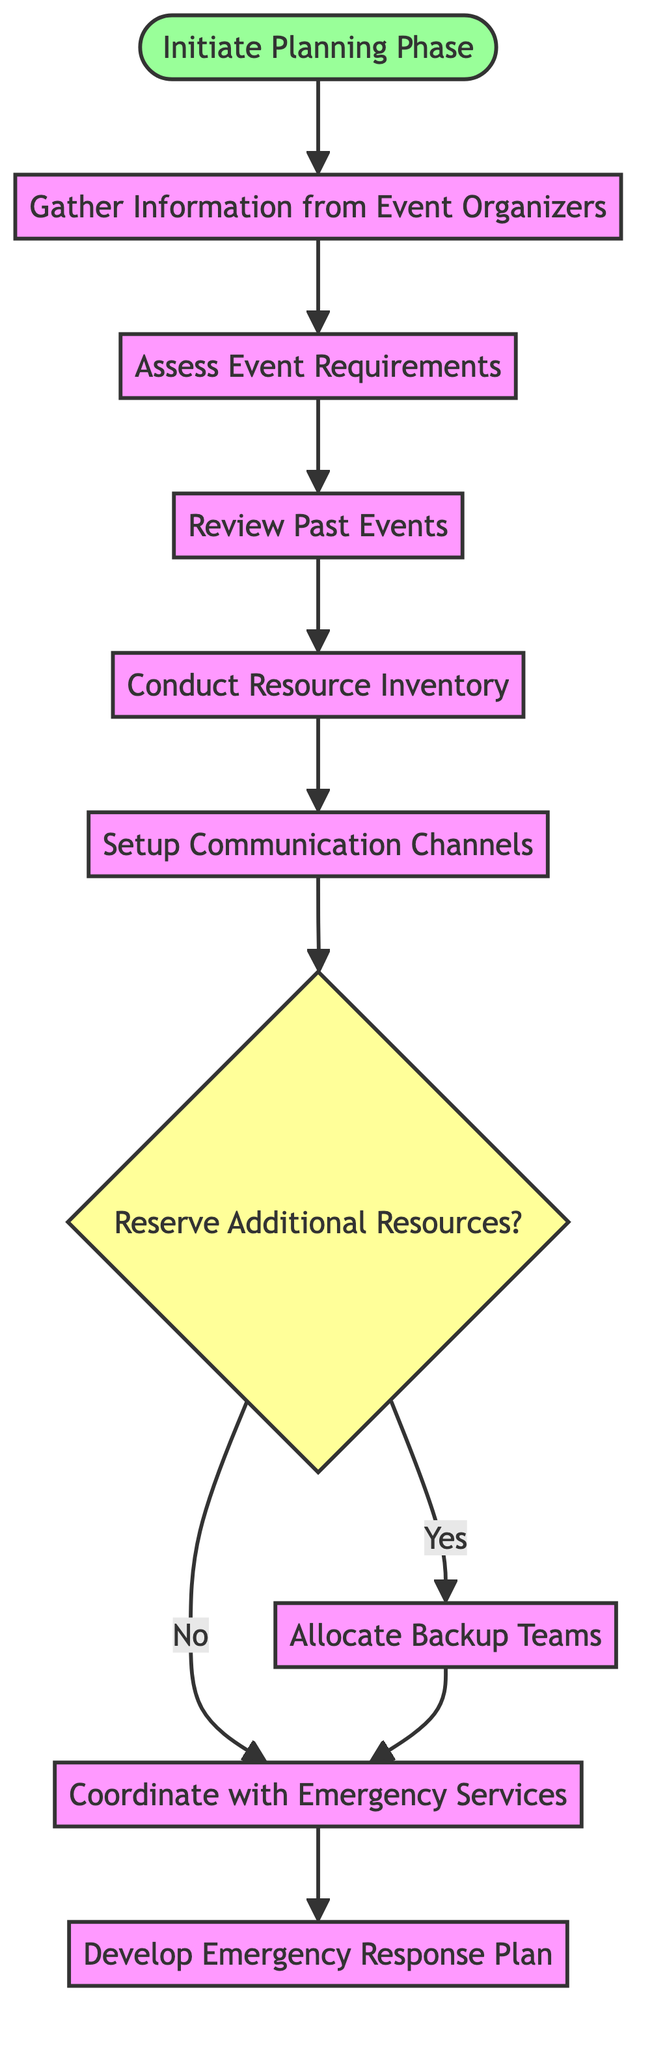What is the first step in the flowchart? The first step is represented by the node labeled "Initiate Planning Phase." It is the start node and directly connects to the next task in the sequence.
Answer: Initiate Planning Phase How many decision nodes are in the flowchart? There is one decision node labeled "Reserve Additional Resources?" which allows for a Yes or No response, impacting the subsequent steps in the flowchart.
Answer: One What is the final action in the flowchart? The final action is shown at the end of the flow, where the process leads to "Develop Emergency Response Plan," marking the completion of the outlined procedures.
Answer: Develop Emergency Response Plan What follows after assessing event requirements? After "Assess Event Requirements," the flowchart indicates that the next step is "Review Past Events." This is a sequential process where key information is reviewed before moving forward.
Answer: Review Past Events If additional resources are not reserved, what is the next step? If "Reserve Additional Resources" is answered with No, the flowchart directs to "Coordinate with Emergency Services," indicating the alternative path based on the decision made.
Answer: Coordinate with Emergency Services What three steps must be followed before setting up communication channels? The three steps are "Conduct Resource Inventory," "Review Past Events," and "Assess Event Requirements." This sequence details the necessary preparation before communication is established.
Answer: Conduct Resource Inventory, Review Past Events, Assess Event Requirements How does the flowchart start, and what follows the starting point? The flowchart starts with "Initiate Planning Phase," which directly leads to "Gather Information from Event Organizers." This establishes the initial phase of the planning process.
Answer: Gather Information from Event Organizers What is the total number of process nodes in the flowchart? The flowchart consists of six process nodes: "Initiate Planning Phase," "Gather Information from Event Organizers," "Assess Event Requirements," "Review Past Events," "Conduct Resource Inventory," and "Setup Communication Channels."
Answer: Six What action do backup teams lead to in the diagram? The action of "Allocate Backup Teams" leads directly to "Coordinate with Emergency Services," establishing a clear pathway for operational readiness in case of an emergency.
Answer: Coordinate with Emergency Services 